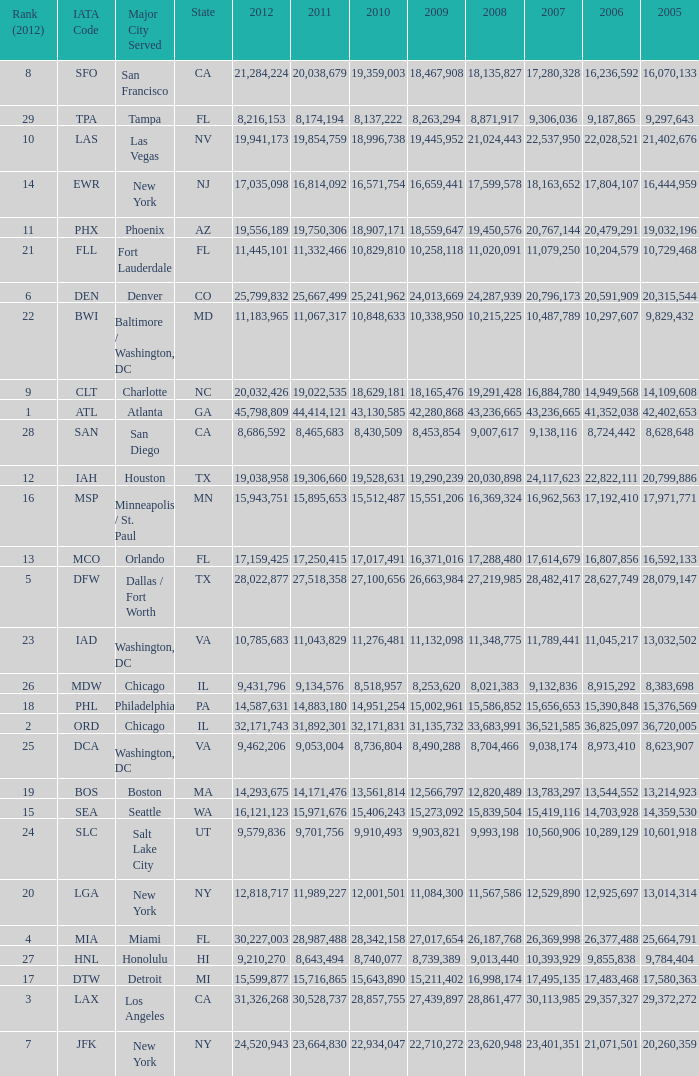What is the greatest 2010 for Miami, Fl? 28342158.0. 